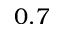<formula> <loc_0><loc_0><loc_500><loc_500>0 . 7</formula> 